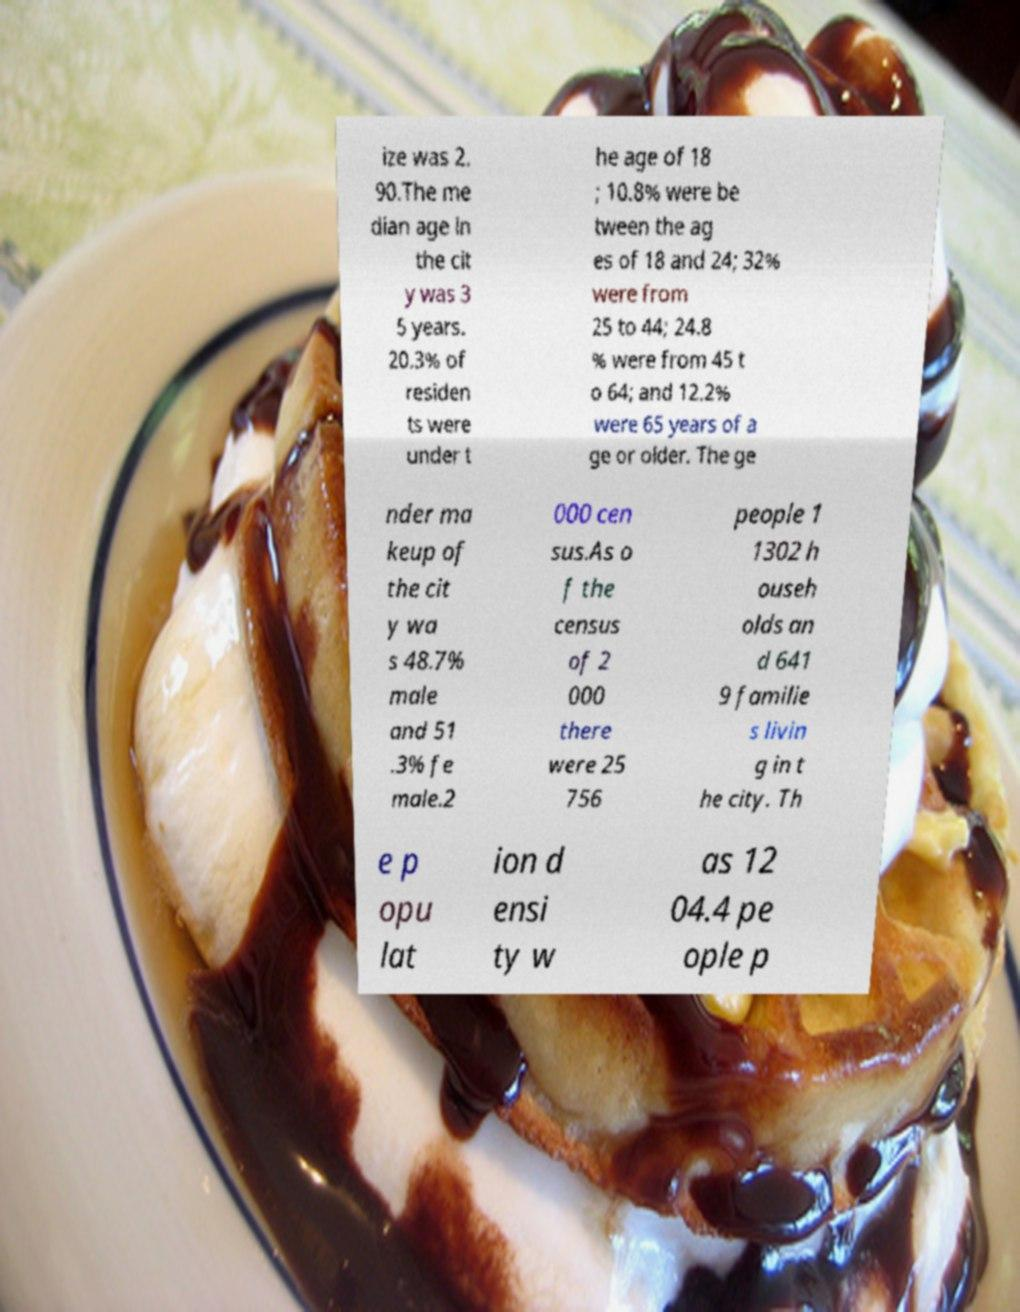Could you assist in decoding the text presented in this image and type it out clearly? ize was 2. 90.The me dian age in the cit y was 3 5 years. 20.3% of residen ts were under t he age of 18 ; 10.8% were be tween the ag es of 18 and 24; 32% were from 25 to 44; 24.8 % were from 45 t o 64; and 12.2% were 65 years of a ge or older. The ge nder ma keup of the cit y wa s 48.7% male and 51 .3% fe male.2 000 cen sus.As o f the census of 2 000 there were 25 756 people 1 1302 h ouseh olds an d 641 9 familie s livin g in t he city. Th e p opu lat ion d ensi ty w as 12 04.4 pe ople p 